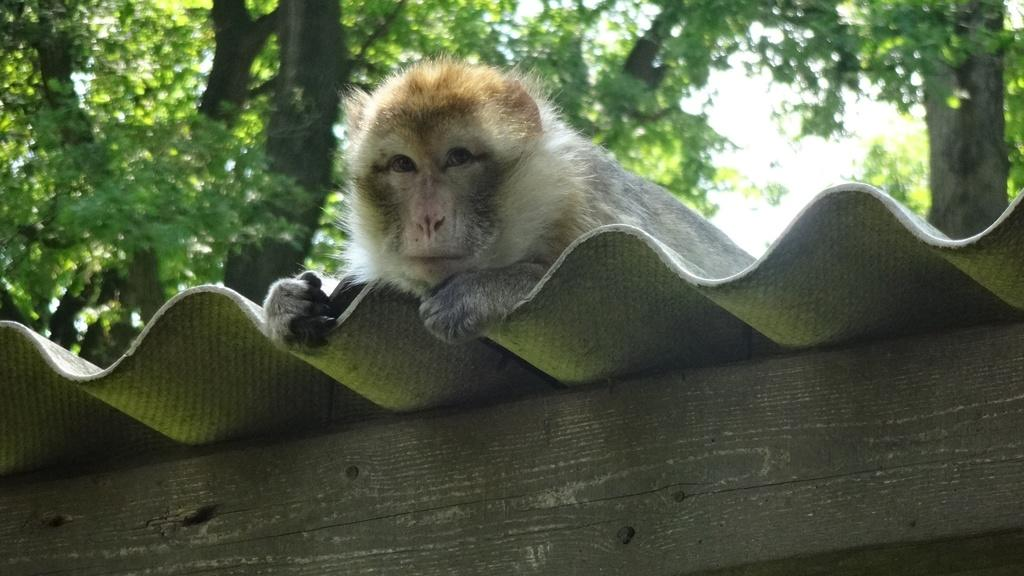What animal is present in the image? There is a monkey in the image. What surface is the monkey on? The monkey is on an asbestos sheet. What object is at the bottom of the image? There is a wooden block at the bottom of the image. What can be seen in the background of the image? Trees and the sky are visible in the background of the image. What type of adjustment does the lawyer make in the image? There is no lawyer present in the image, so no adjustment can be made by a lawyer. What season is depicted in the image? The provided facts do not mention the season, so it cannot be determined from the image. 